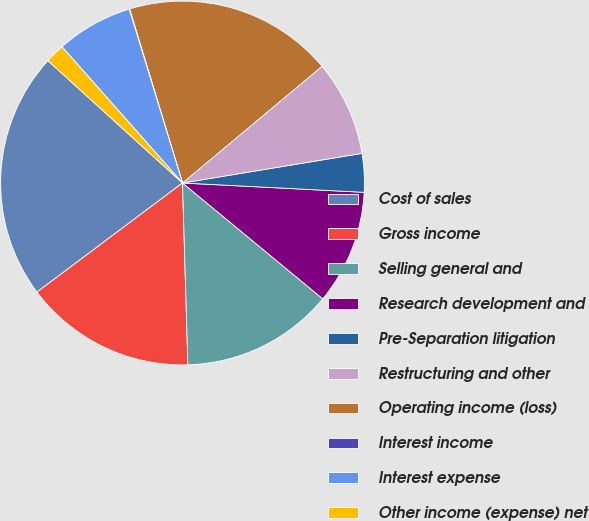Convert chart. <chart><loc_0><loc_0><loc_500><loc_500><pie_chart><fcel>Cost of sales<fcel>Gross income<fcel>Selling general and<fcel>Research development and<fcel>Pre-Separation litigation<fcel>Restructuring and other<fcel>Operating income (loss)<fcel>Interest income<fcel>Interest expense<fcel>Other income (expense) net<nl><fcel>21.98%<fcel>15.23%<fcel>13.54%<fcel>10.17%<fcel>3.42%<fcel>8.48%<fcel>18.61%<fcel>0.04%<fcel>6.79%<fcel>1.73%<nl></chart> 